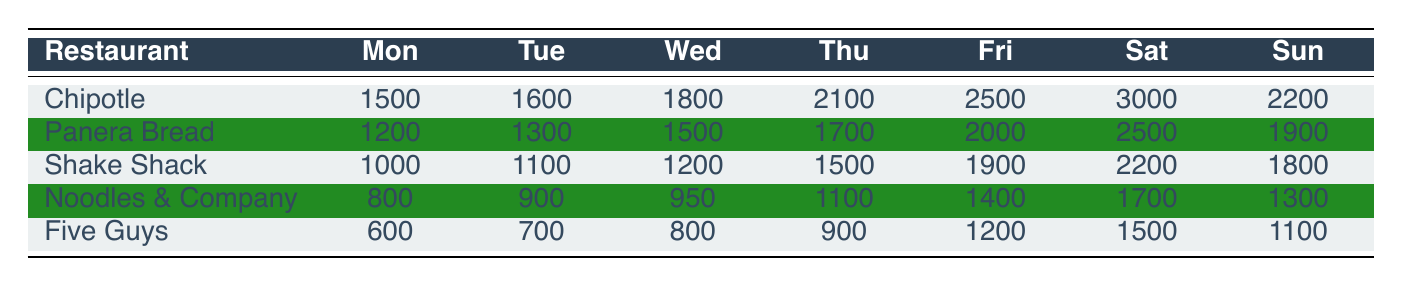What is the highest foot traffic recorded on a Saturday? The table shows that Chipotle has the highest foot traffic on Saturday with a value of 3000.
Answer: 3000 Which restaurant has the lowest foot traffic on Wednesday? The table indicates that Five Guys has the lowest foot traffic on Wednesday with a value of 800.
Answer: 800 What is the average foot traffic for Shake Shack across all days? To find the average for Shake Shack, sum all its daily traffic: (1000 + 1100 + 1200 + 1500 + 1900 + 2200 + 1800) = 11700. Since there are 7 days, the average is 11700/7 = 1671.43.
Answer: 1671.43 On which day of the week does Panera Bread have the highest foot traffic? From the table, Thursday shows the highest foot traffic for Panera Bread, with a value of 1700.
Answer: Thursday Is the foot traffic for Noodles & Company higher on Fridays or Sundays? Comparing both values from the table, Noodles & Company has 1400 on Friday and 1300 on Sunday, thus it is higher on Friday.
Answer: Yes What is the total foot traffic for all restaurants on Fridays? To calculate the total for Fridays, sum: 2500 (Chipotle) + 2000 (Panera Bread) + 1900 (Shake Shack) + 1400 (Noodles & Company) + 1200 (Five Guys) = 10000.
Answer: 10000 Which restaurant has more foot traffic on Tuesdays than Five Guys? Only Chipotle, Panera Bread, Shake Shack, and Noodles & Company have foot traffic higher than Five Guys' 700; specifically, Chipotle (1600), Panera Bread (1300), Shake Shack (1100), and Noodles & Company (900).
Answer: Yes What is the difference in foot traffic between Friday and Monday for Chipotle? Chipotle had 2500 on Friday and 1500 on Monday. The difference is 2500 - 1500 = 1000.
Answer: 1000 Which day shows the most consistent foot traffic across all restaurants? By examining the data for consistency, the results for Tuesday show a smaller variability across restaurants, indicating a more even distribution compared to other days.
Answer: Tuesday 